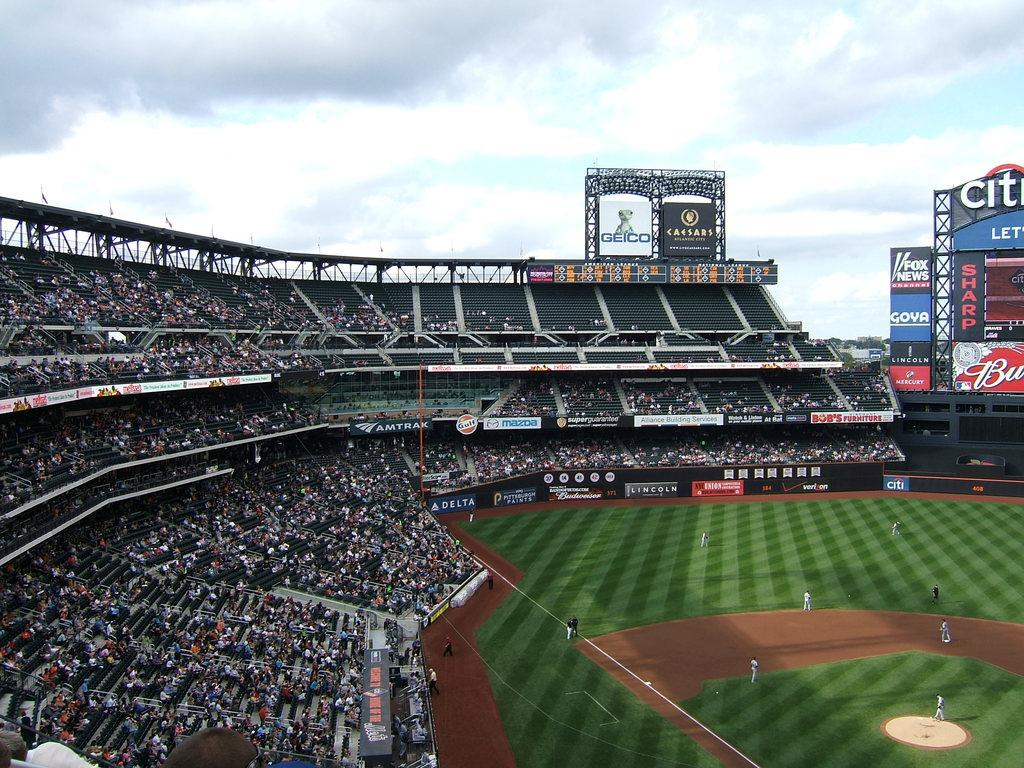<image>
Offer a succinct explanation of the picture presented. A baseball stadium with a Geico advertisement visible above the stands 